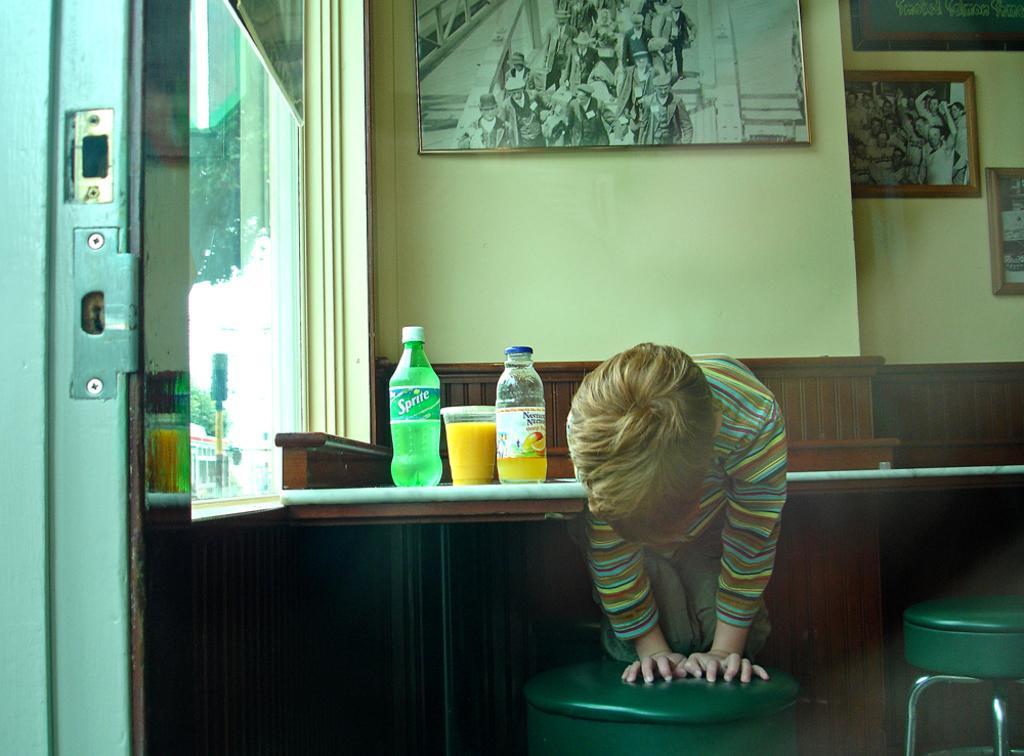How would you summarize this image in a sentence or two? In this picture we can see a boy seated on the chair, in front of him we can find a glass and couple of bottles on the table, and also we can see couple of wall paintings on the wall, in the background we can find a traffic signal and couple of trees. 